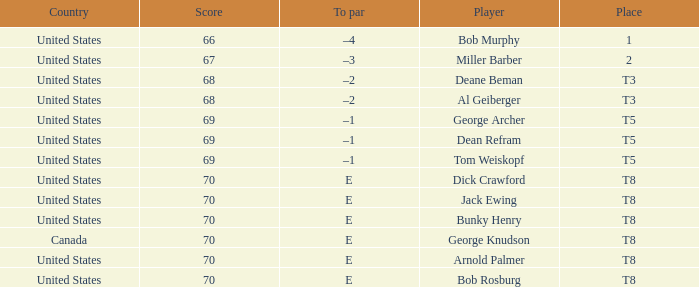When Bunky Henry of the United States scored higher than 67 and his To par was e, what was his place? T8. Could you parse the entire table? {'header': ['Country', 'Score', 'To par', 'Player', 'Place'], 'rows': [['United States', '66', '–4', 'Bob Murphy', '1'], ['United States', '67', '–3', 'Miller Barber', '2'], ['United States', '68', '–2', 'Deane Beman', 'T3'], ['United States', '68', '–2', 'Al Geiberger', 'T3'], ['United States', '69', '–1', 'George Archer', 'T5'], ['United States', '69', '–1', 'Dean Refram', 'T5'], ['United States', '69', '–1', 'Tom Weiskopf', 'T5'], ['United States', '70', 'E', 'Dick Crawford', 'T8'], ['United States', '70', 'E', 'Jack Ewing', 'T8'], ['United States', '70', 'E', 'Bunky Henry', 'T8'], ['Canada', '70', 'E', 'George Knudson', 'T8'], ['United States', '70', 'E', 'Arnold Palmer', 'T8'], ['United States', '70', 'E', 'Bob Rosburg', 'T8']]} 